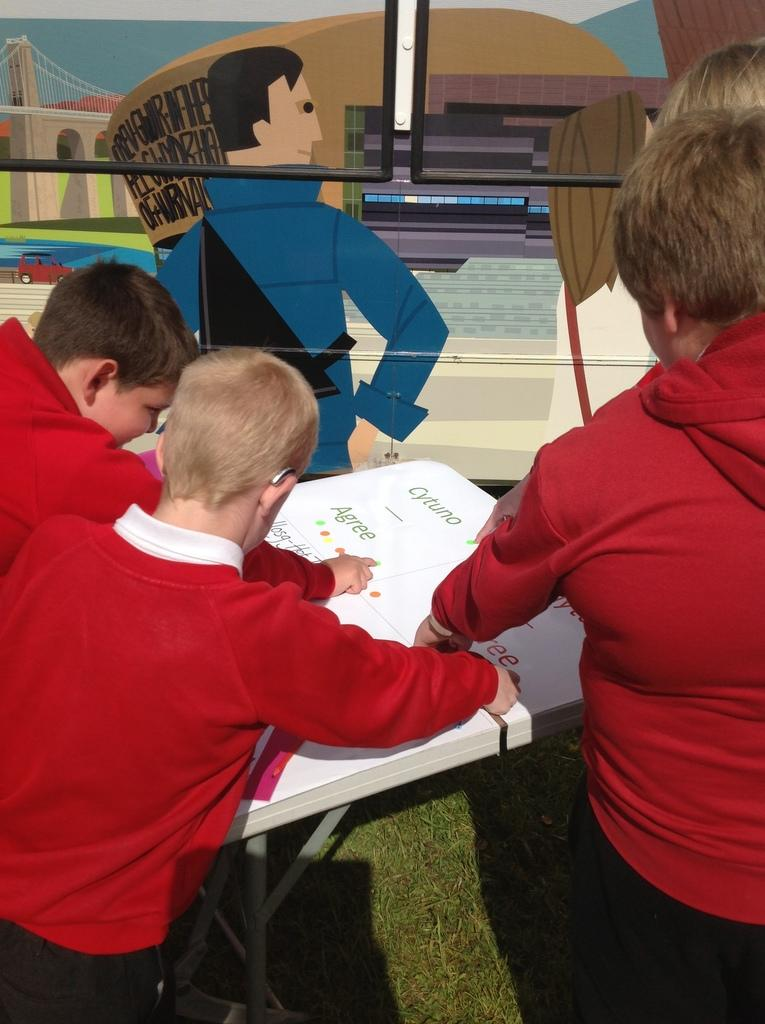How many boys are present in the image? There are three boys standing in the image. What is the location of the table in the image? The table is in the image, but its exact location is not specified. What type of images can be seen on an object in the image? There is a painting of cartoon images on an object in the image. What type of vegetation is visible at the bottom of the image? Grass is visible at the bottom of the image. What type of wire is being used by the kitty in the image? There is no kitty present in the image, and therefore no wire being used by a kitty. 